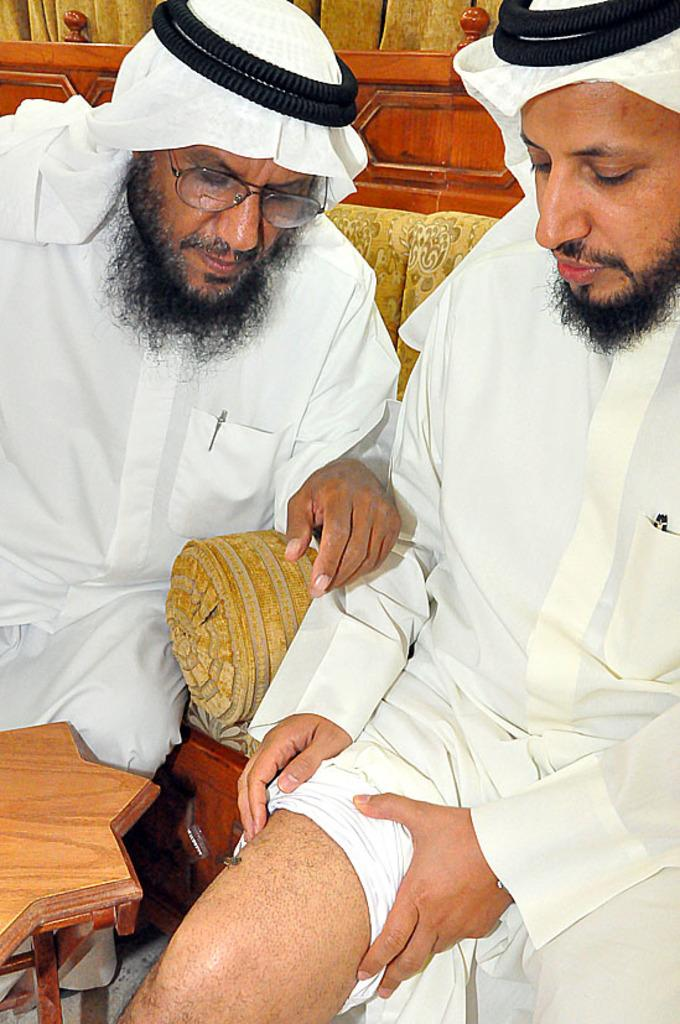How many people are sitting on the sofa in the image? There are two persons sitting on the sofa in the image. Can you describe the appearance of one of the persons? One person is wearing glasses. What are the two persons wearing on their heads? Both persons are wearing a white scarf with black round things on their heads. What can be seen on the left side of the image? There is a table on the left side of the image. What type of treatment is being administered to the person wearing glasses in the image? There is no indication in the image that any treatment is being administered to the person wearing glasses. 